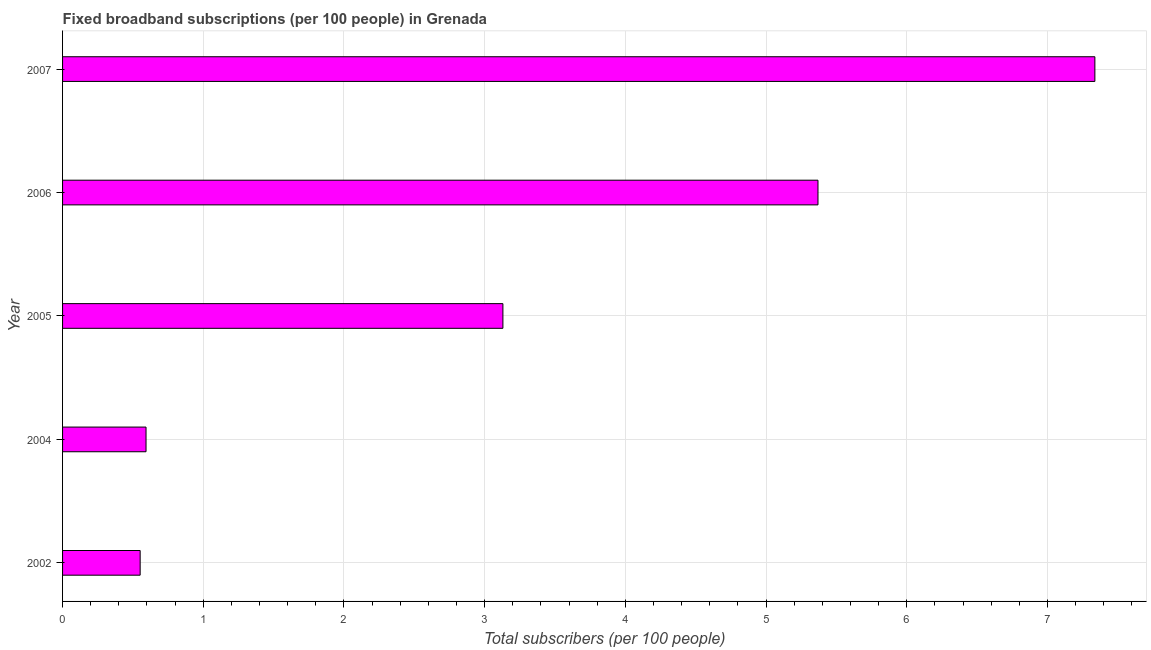Does the graph contain any zero values?
Give a very brief answer. No. Does the graph contain grids?
Your answer should be very brief. Yes. What is the title of the graph?
Give a very brief answer. Fixed broadband subscriptions (per 100 people) in Grenada. What is the label or title of the X-axis?
Your answer should be very brief. Total subscribers (per 100 people). What is the total number of fixed broadband subscriptions in 2007?
Provide a succinct answer. 7.34. Across all years, what is the maximum total number of fixed broadband subscriptions?
Make the answer very short. 7.34. Across all years, what is the minimum total number of fixed broadband subscriptions?
Your answer should be compact. 0.55. In which year was the total number of fixed broadband subscriptions maximum?
Your answer should be very brief. 2007. What is the sum of the total number of fixed broadband subscriptions?
Your response must be concise. 16.98. What is the difference between the total number of fixed broadband subscriptions in 2002 and 2006?
Your answer should be very brief. -4.82. What is the average total number of fixed broadband subscriptions per year?
Your answer should be very brief. 3.4. What is the median total number of fixed broadband subscriptions?
Your response must be concise. 3.13. Do a majority of the years between 2004 and 2005 (inclusive) have total number of fixed broadband subscriptions greater than 1.8 ?
Provide a short and direct response. No. What is the ratio of the total number of fixed broadband subscriptions in 2005 to that in 2007?
Your answer should be very brief. 0.43. Is the total number of fixed broadband subscriptions in 2002 less than that in 2005?
Your answer should be very brief. Yes. What is the difference between the highest and the second highest total number of fixed broadband subscriptions?
Ensure brevity in your answer.  1.97. What is the difference between the highest and the lowest total number of fixed broadband subscriptions?
Provide a succinct answer. 6.79. How many years are there in the graph?
Provide a short and direct response. 5. What is the difference between two consecutive major ticks on the X-axis?
Give a very brief answer. 1. Are the values on the major ticks of X-axis written in scientific E-notation?
Provide a succinct answer. No. What is the Total subscribers (per 100 people) of 2002?
Keep it short and to the point. 0.55. What is the Total subscribers (per 100 people) of 2004?
Your answer should be compact. 0.59. What is the Total subscribers (per 100 people) in 2005?
Provide a short and direct response. 3.13. What is the Total subscribers (per 100 people) of 2006?
Ensure brevity in your answer.  5.37. What is the Total subscribers (per 100 people) in 2007?
Offer a very short reply. 7.34. What is the difference between the Total subscribers (per 100 people) in 2002 and 2004?
Provide a succinct answer. -0.04. What is the difference between the Total subscribers (per 100 people) in 2002 and 2005?
Make the answer very short. -2.58. What is the difference between the Total subscribers (per 100 people) in 2002 and 2006?
Provide a succinct answer. -4.82. What is the difference between the Total subscribers (per 100 people) in 2002 and 2007?
Your response must be concise. -6.79. What is the difference between the Total subscribers (per 100 people) in 2004 and 2005?
Your response must be concise. -2.54. What is the difference between the Total subscribers (per 100 people) in 2004 and 2006?
Your answer should be very brief. -4.78. What is the difference between the Total subscribers (per 100 people) in 2004 and 2007?
Provide a short and direct response. -6.74. What is the difference between the Total subscribers (per 100 people) in 2005 and 2006?
Your answer should be very brief. -2.24. What is the difference between the Total subscribers (per 100 people) in 2005 and 2007?
Make the answer very short. -4.21. What is the difference between the Total subscribers (per 100 people) in 2006 and 2007?
Offer a very short reply. -1.97. What is the ratio of the Total subscribers (per 100 people) in 2002 to that in 2005?
Offer a very short reply. 0.18. What is the ratio of the Total subscribers (per 100 people) in 2002 to that in 2006?
Your response must be concise. 0.1. What is the ratio of the Total subscribers (per 100 people) in 2002 to that in 2007?
Make the answer very short. 0.07. What is the ratio of the Total subscribers (per 100 people) in 2004 to that in 2005?
Your answer should be compact. 0.19. What is the ratio of the Total subscribers (per 100 people) in 2004 to that in 2006?
Ensure brevity in your answer.  0.11. What is the ratio of the Total subscribers (per 100 people) in 2004 to that in 2007?
Offer a terse response. 0.08. What is the ratio of the Total subscribers (per 100 people) in 2005 to that in 2006?
Provide a short and direct response. 0.58. What is the ratio of the Total subscribers (per 100 people) in 2005 to that in 2007?
Provide a short and direct response. 0.43. What is the ratio of the Total subscribers (per 100 people) in 2006 to that in 2007?
Make the answer very short. 0.73. 